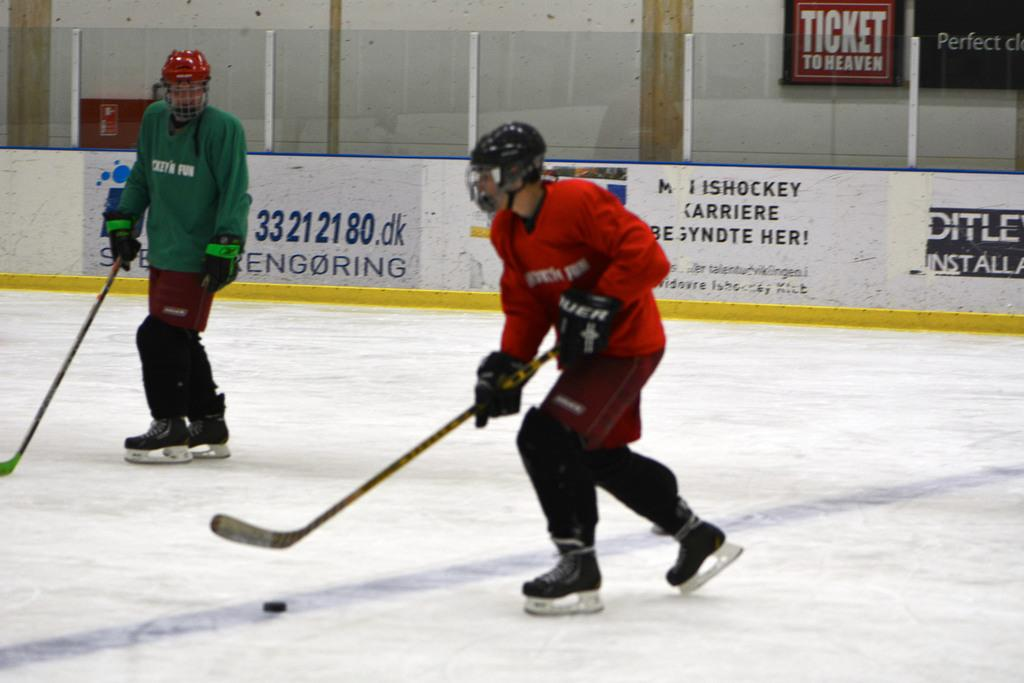<image>
Summarize the visual content of the image. some hockey players on the ice with a banner on the backboard that says 'ishockey carriere' on it 